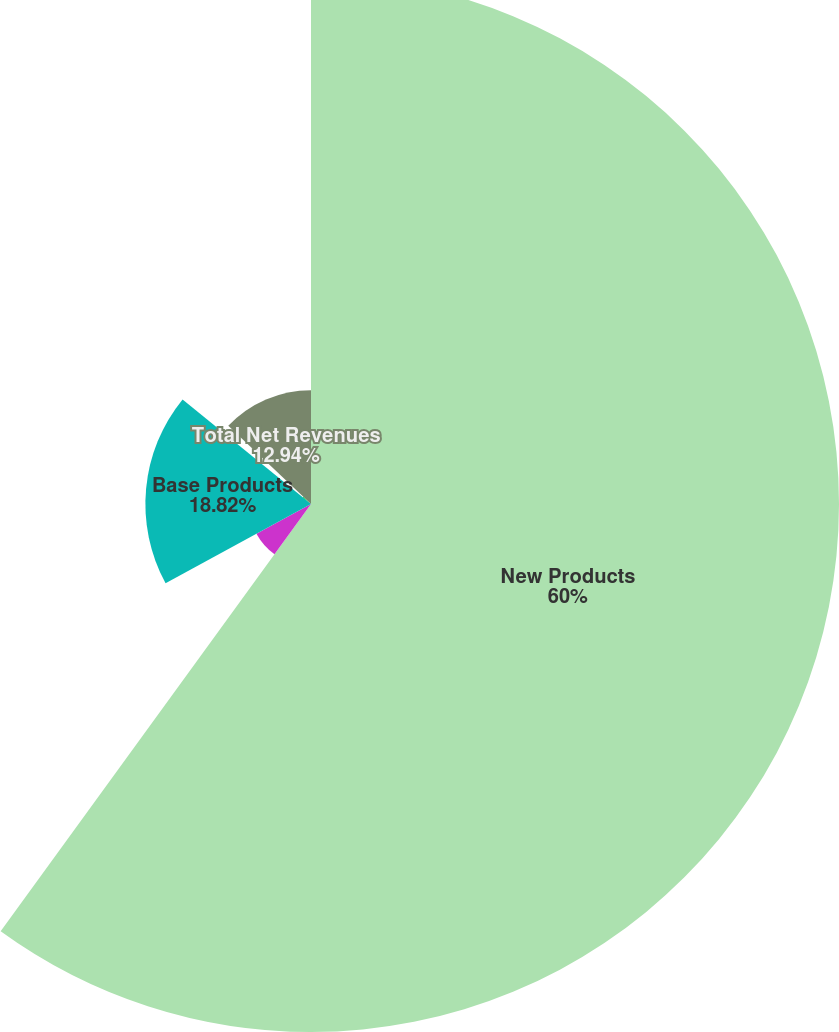Convert chart. <chart><loc_0><loc_0><loc_500><loc_500><pie_chart><fcel>New Products<fcel>Mainstream Products<fcel>Base Products<fcel>Support Products<fcel>Total Net Revenues<nl><fcel>60.0%<fcel>7.06%<fcel>18.82%<fcel>1.18%<fcel>12.94%<nl></chart> 